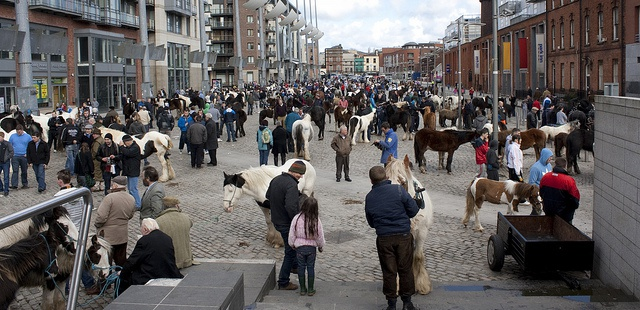Describe the objects in this image and their specific colors. I can see horse in black, gray, darkgray, and maroon tones, people in black, gray, darkgray, and maroon tones, horse in black, gray, and darkgray tones, people in black and gray tones, and people in black and gray tones in this image. 